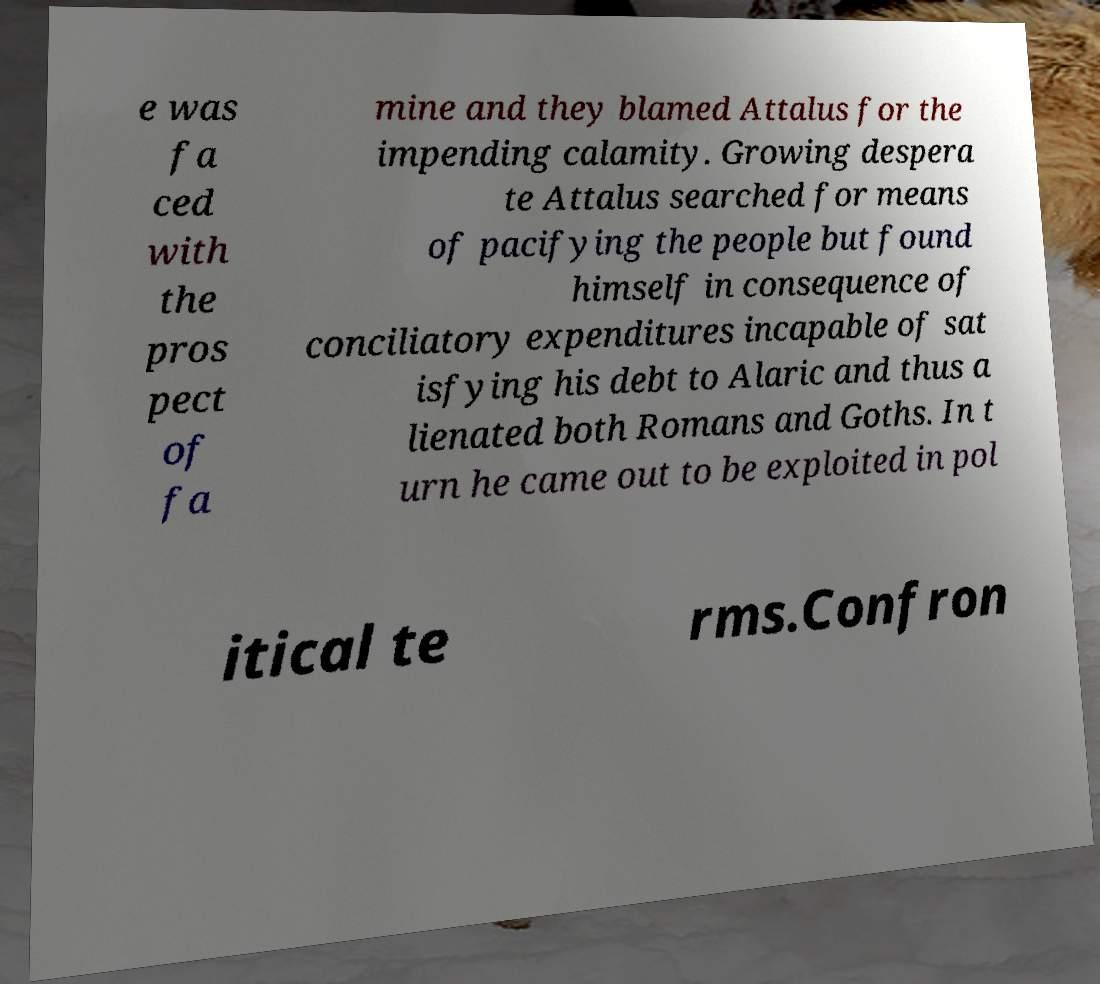Could you assist in decoding the text presented in this image and type it out clearly? e was fa ced with the pros pect of fa mine and they blamed Attalus for the impending calamity. Growing despera te Attalus searched for means of pacifying the people but found himself in consequence of conciliatory expenditures incapable of sat isfying his debt to Alaric and thus a lienated both Romans and Goths. In t urn he came out to be exploited in pol itical te rms.Confron 